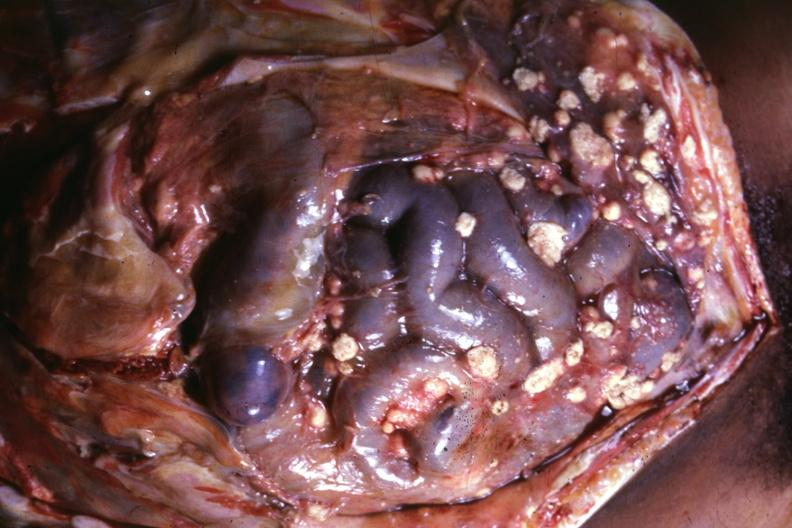does omphalocele show opened abdomen with large lesions typical?
Answer the question using a single word or phrase. No 